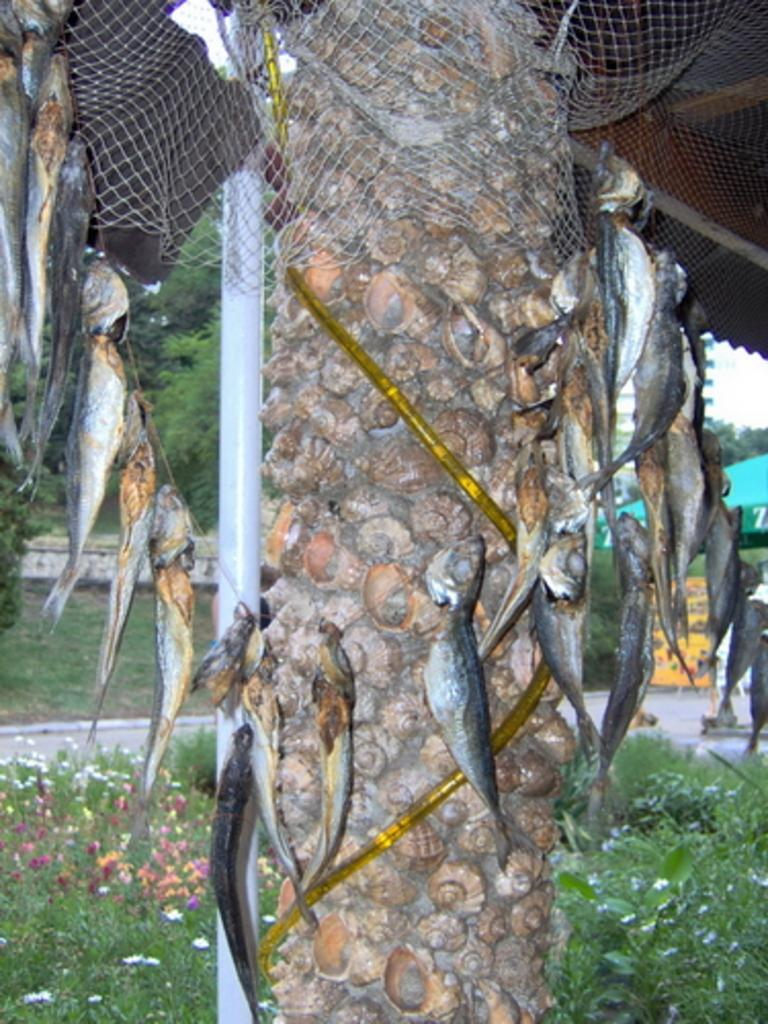What is the main subject in the middle of the image? There is a tree in the middle of the image. What is unique about the tree in the image? The tree has fishes depicted as part of part of it. What other plants can be seen at the bottom of the image? There are flower plants at the bottom of the image. Are there any fairies flying around the tree in the image? There are no fairies present in the image; it only features a tree with fishes and flower plants. What type of steel structure can be seen supporting the tree in the image? There is no steel structure present in the image; the tree is depicted as a part of the artwork or design. 